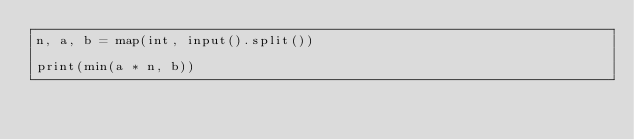<code> <loc_0><loc_0><loc_500><loc_500><_Python_>n, a, b = map(int, input().split())

print(min(a * n, b))</code> 